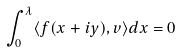<formula> <loc_0><loc_0><loc_500><loc_500>\int _ { 0 } ^ { \lambda } \langle f ( x + i y ) , v \rangle d x = 0</formula> 